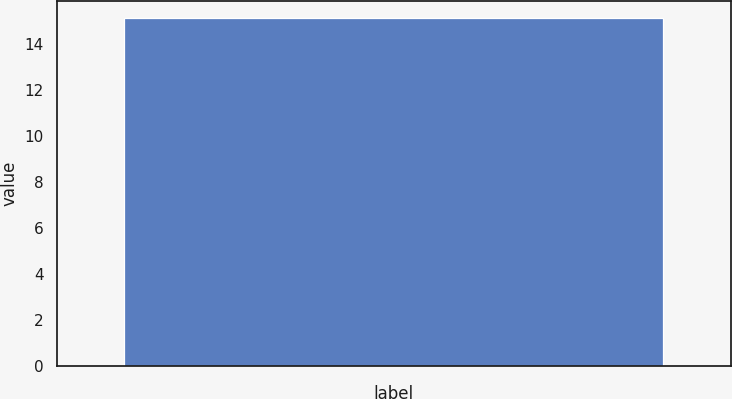Convert chart to OTSL. <chart><loc_0><loc_0><loc_500><loc_500><bar_chart><ecel><nl><fcel>15.1<nl></chart> 